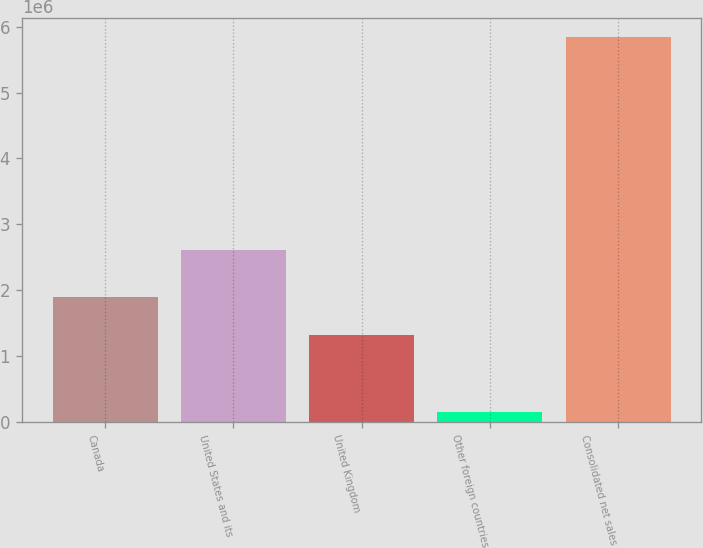Convert chart to OTSL. <chart><loc_0><loc_0><loc_500><loc_500><bar_chart><fcel>Canada<fcel>United States and its<fcel>United Kingdom<fcel>Other foreign countries<fcel>Consolidated net sales<nl><fcel>1.89339e+06<fcel>2.61224e+06<fcel>1.32449e+06<fcel>155992<fcel>5.84498e+06<nl></chart> 